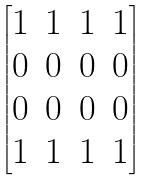<formula> <loc_0><loc_0><loc_500><loc_500>\begin{bmatrix} 1 & 1 & 1 & 1 \\ 0 & 0 & 0 & 0 \\ 0 & 0 & 0 & 0 \\ 1 & 1 & 1 & 1 \end{bmatrix}</formula> 